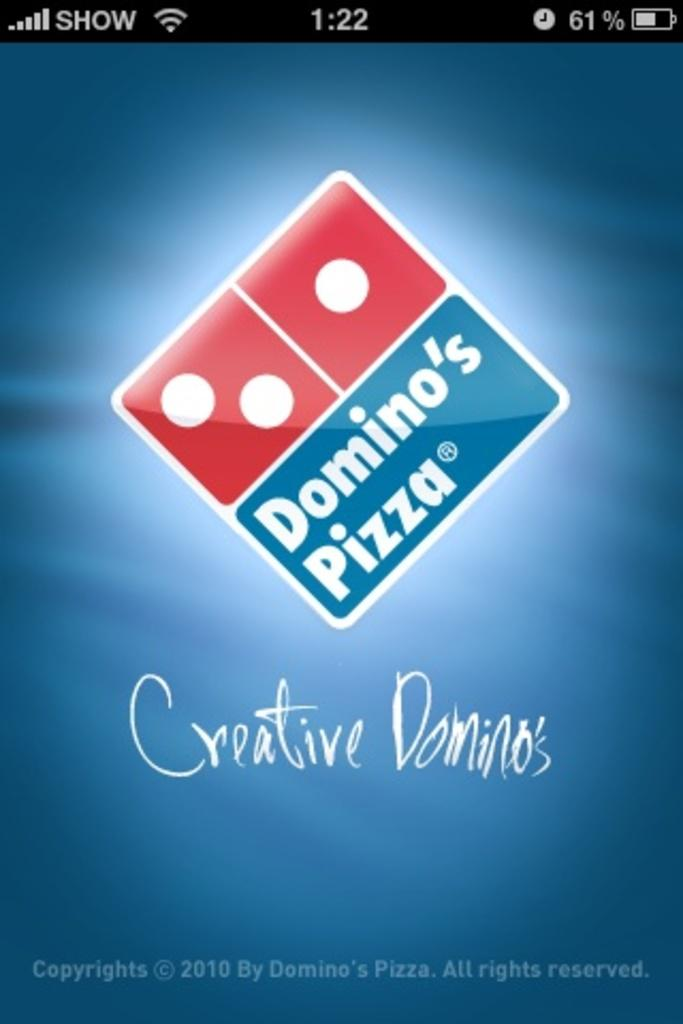<image>
Write a terse but informative summary of the picture. A phone screen shot that shows a Domino's Pizza ad. 